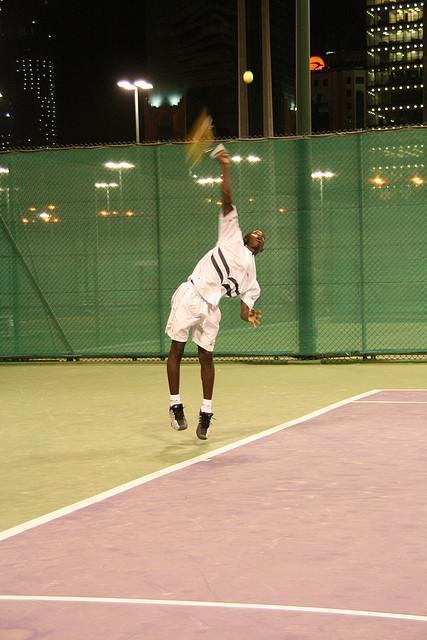What is the man swinging?
Select the accurate answer and provide explanation: 'Answer: answer
Rationale: rationale.'
Options: Baseball bat, tennis racquet, oar, stuffed animal. Answer: tennis racquet.
Rationale: Serena williams made her career using this device. 